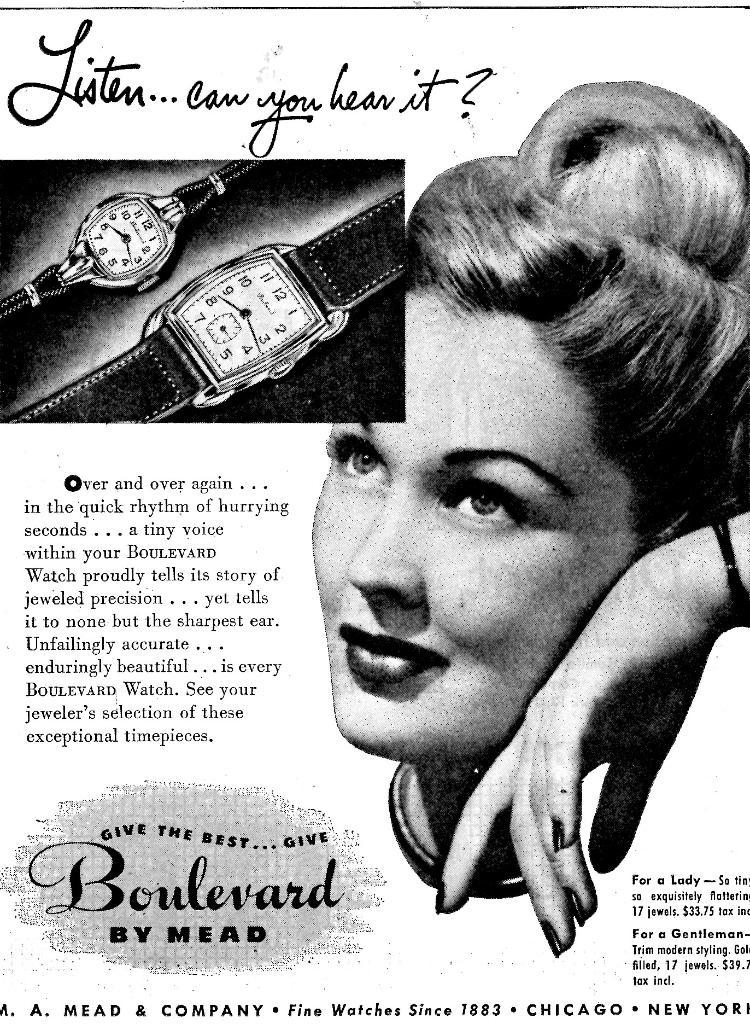<image>
Share a concise interpretation of the image provided. An advertisement for a watch that is titled Listen... can you hear it 